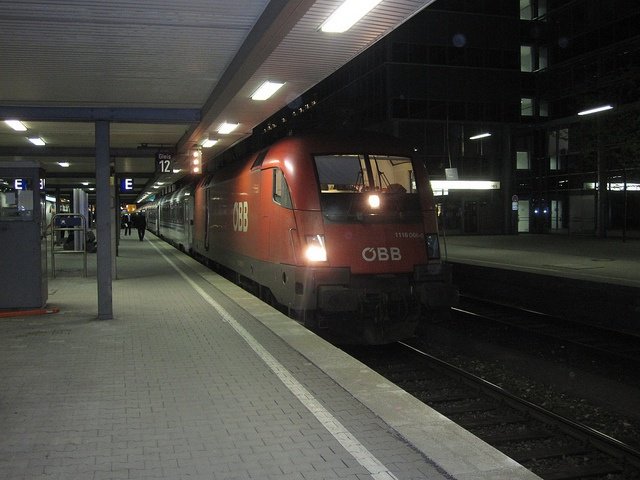Describe the objects in this image and their specific colors. I can see train in black, maroon, and gray tones, people in black, maroon, and gray tones, people in black, gray, darkgreen, and purple tones, and people in black, gray, and olive tones in this image. 